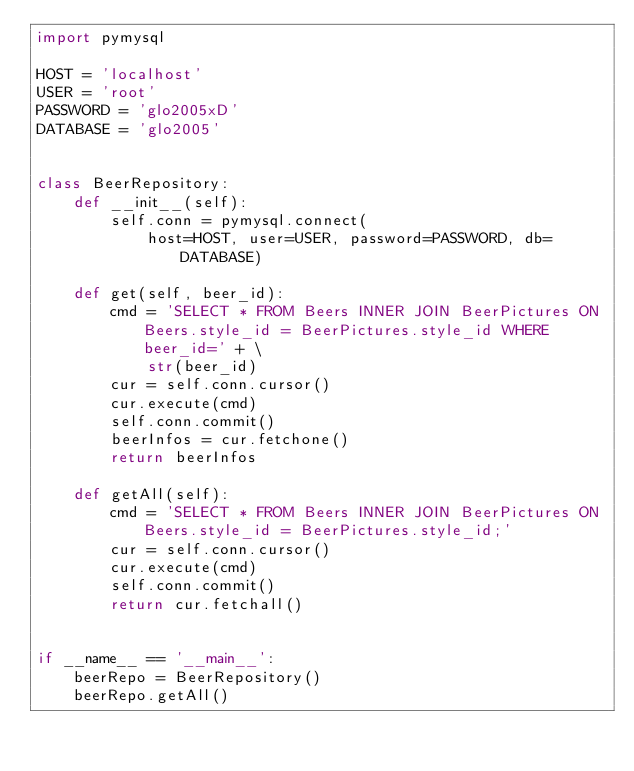Convert code to text. <code><loc_0><loc_0><loc_500><loc_500><_Python_>import pymysql

HOST = 'localhost'
USER = 'root'
PASSWORD = 'glo2005xD'
DATABASE = 'glo2005'


class BeerRepository:
    def __init__(self):
        self.conn = pymysql.connect(
            host=HOST, user=USER, password=PASSWORD, db=DATABASE)

    def get(self, beer_id):
        cmd = 'SELECT * FROM Beers INNER JOIN BeerPictures ON Beers.style_id = BeerPictures.style_id WHERE beer_id=' + \
            str(beer_id)
        cur = self.conn.cursor()
        cur.execute(cmd)
        self.conn.commit()
        beerInfos = cur.fetchone()
        return beerInfos

    def getAll(self):
        cmd = 'SELECT * FROM Beers INNER JOIN BeerPictures ON Beers.style_id = BeerPictures.style_id;'
        cur = self.conn.cursor()
        cur.execute(cmd)
        self.conn.commit()
        return cur.fetchall()


if __name__ == '__main__':
    beerRepo = BeerRepository()
    beerRepo.getAll()
</code> 